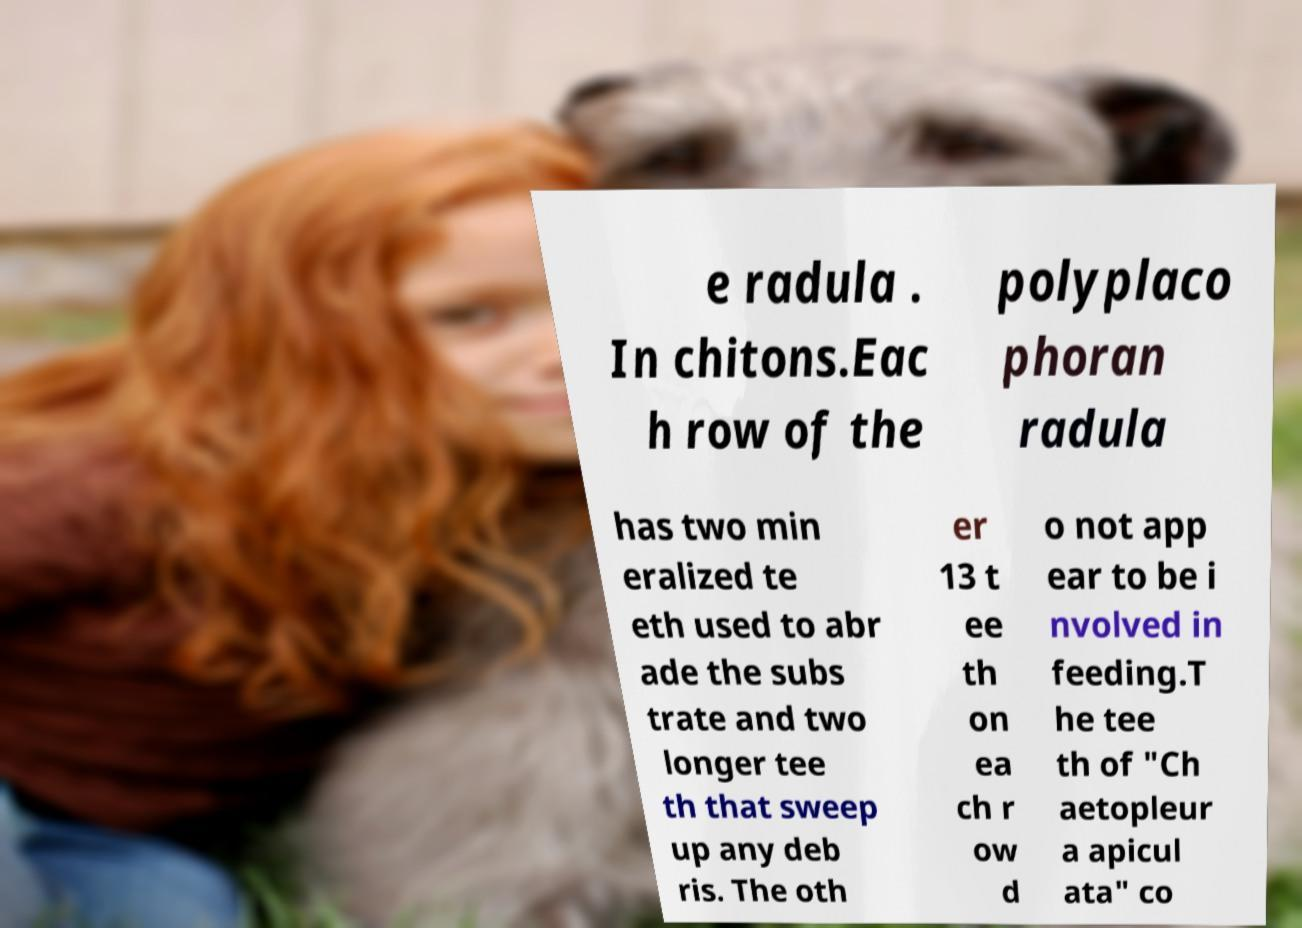Can you accurately transcribe the text from the provided image for me? e radula . In chitons.Eac h row of the polyplaco phoran radula has two min eralized te eth used to abr ade the subs trate and two longer tee th that sweep up any deb ris. The oth er 13 t ee th on ea ch r ow d o not app ear to be i nvolved in feeding.T he tee th of "Ch aetopleur a apicul ata" co 